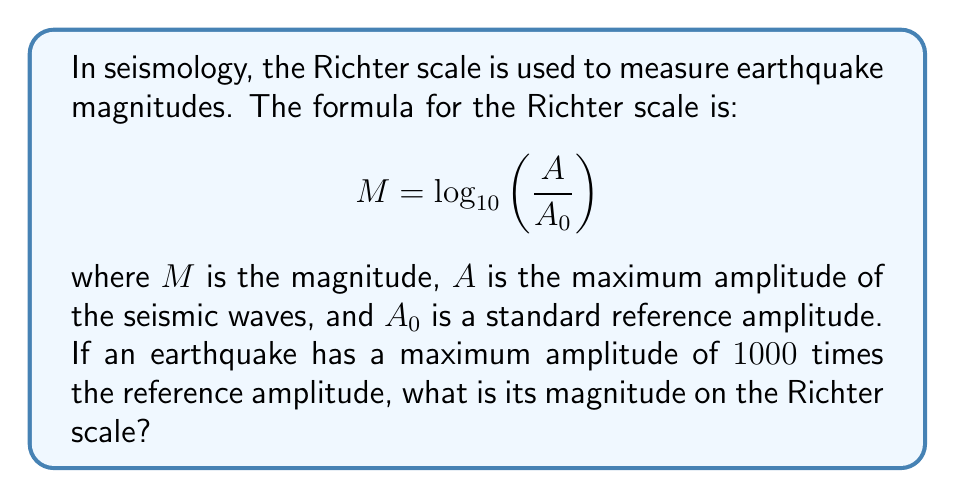Help me with this question. Let's approach this step-by-step:

1) We are given the formula: $M = \log_{10}\left(\frac{A}{A_0}\right)$

2) We're told that the earthquake's amplitude is 1000 times the reference amplitude. This means:

   $\frac{A}{A_0} = 1000$

3) Substituting this into our formula:

   $M = \log_{10}(1000)$

4) Now, we need to evaluate $\log_{10}(1000)$. We can do this by recalling that:

   $1000 = 10^3$

5) Therefore:

   $M = \log_{10}(10^3) = 3$

   This is because the logarithm and exponent cancel each other out when they have the same base.

Thus, the magnitude of the earthquake on the Richter scale is 3.
Answer: 3 